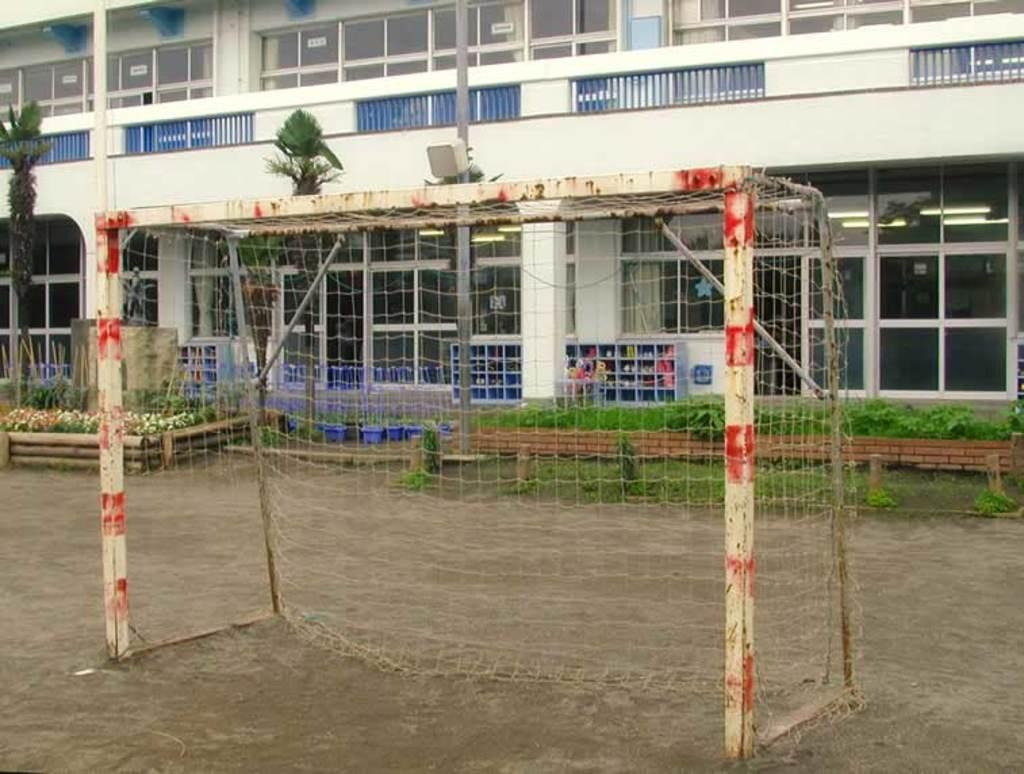What is the main structure visible in the image? There is a goal post in the image. What other type of structure can be seen in the image? There is a building in the image. What type of vegetation is present in front of the building? Small plants are present in front of the building. What type of curtain can be seen hanging from the library in the image? There is no library or curtain present in the image. 